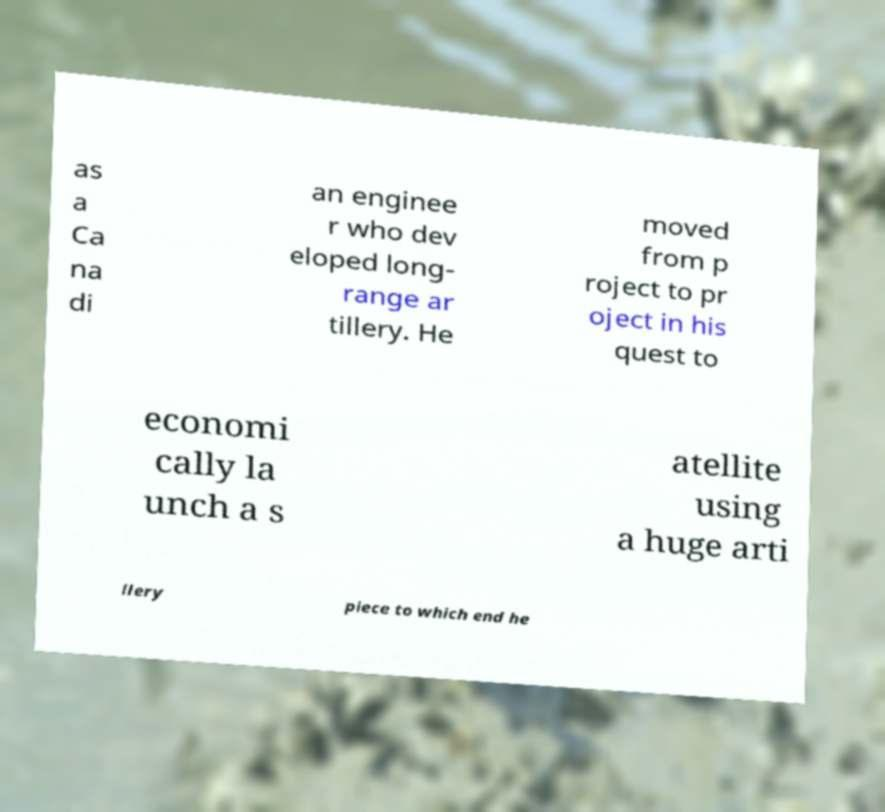Could you extract and type out the text from this image? as a Ca na di an enginee r who dev eloped long- range ar tillery. He moved from p roject to pr oject in his quest to economi cally la unch a s atellite using a huge arti llery piece to which end he 